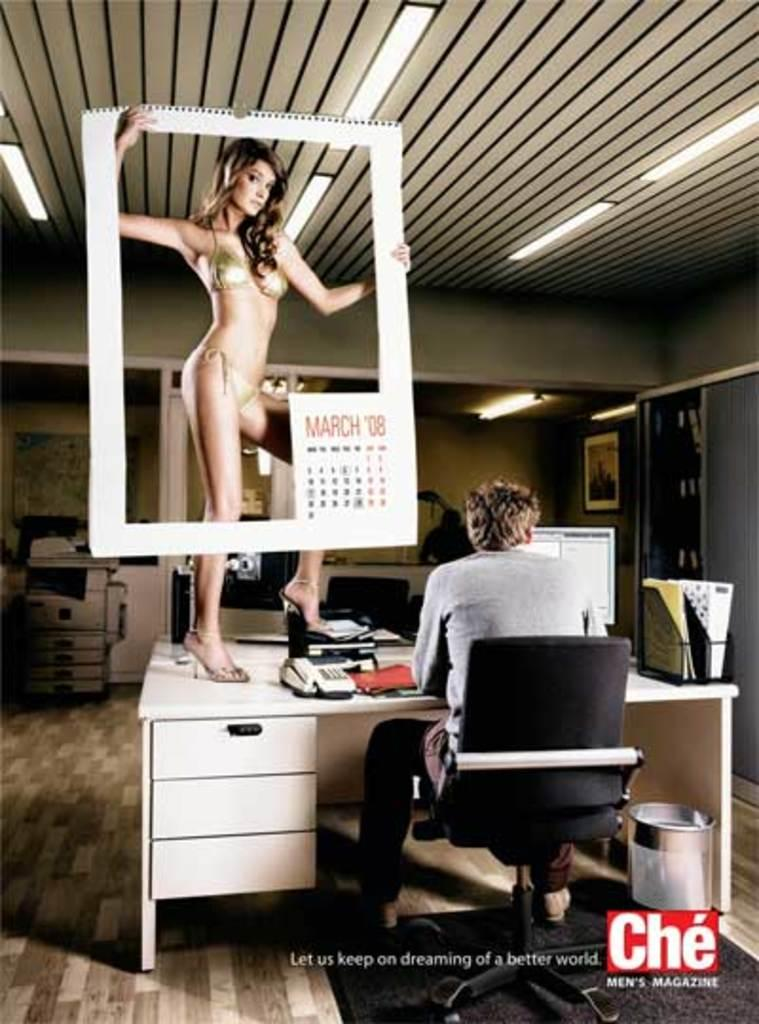Who is present in the image? There is a man and a woman in the image. What is the man doing in the image? The man is sitting on a chair in the image. Where is the chair located in relation to the table? The chair is near a table in the image. What is the woman doing in the image? The woman is standing on the table in the image. Reasoning: Let' Let's think step by step in order to produce the conversation. We start by identifying the people present in the image, which are a man and a woman. Then, we describe the actions and positions of each person in relation to the furniture, specifically the chair and table. Each question is designed to elicit a specific detail about the image that is known from the provided facts. Absurd Question/Answer: What type of knot is the man tying on the table? There is no knot present in the image, and the man is not tying anything. 